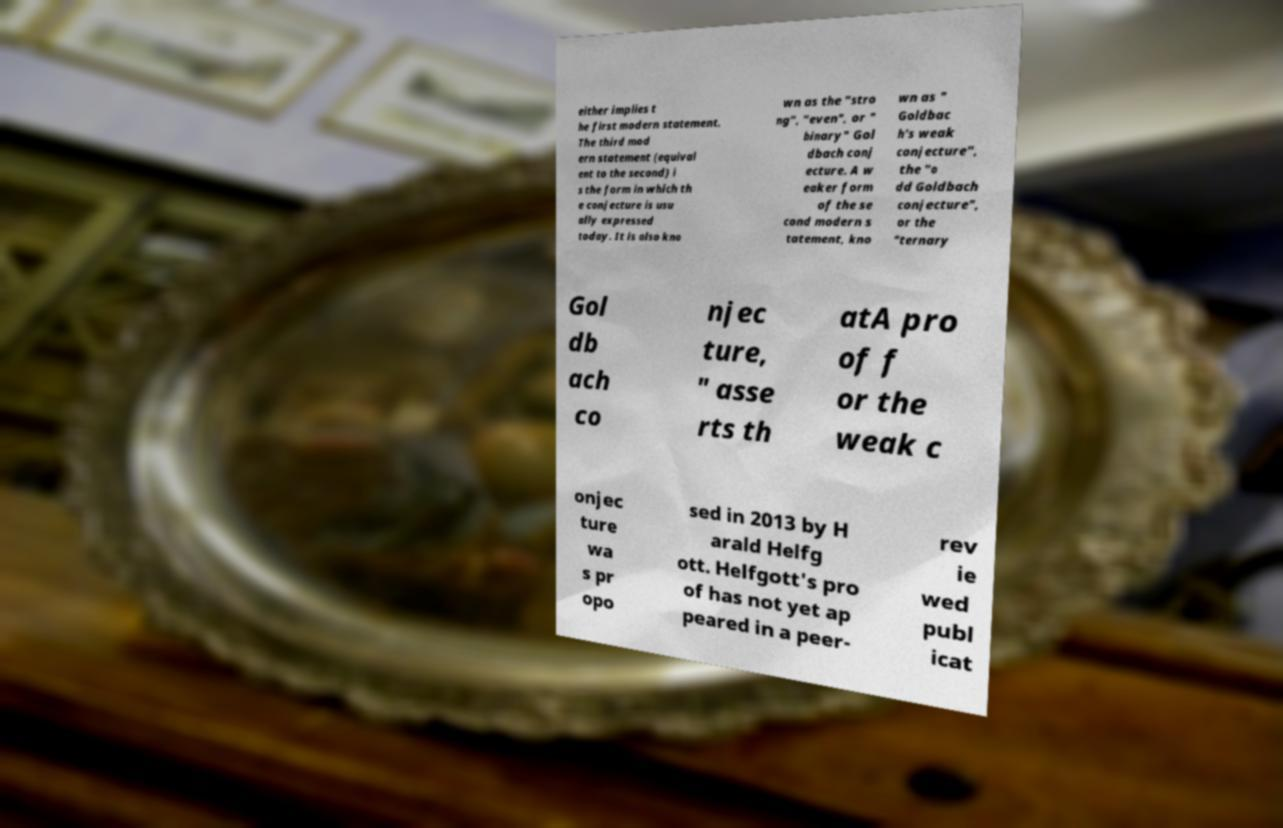For documentation purposes, I need the text within this image transcribed. Could you provide that? either implies t he first modern statement. The third mod ern statement (equival ent to the second) i s the form in which th e conjecture is usu ally expressed today. It is also kno wn as the "stro ng", "even", or " binary" Gol dbach conj ecture. A w eaker form of the se cond modern s tatement, kno wn as " Goldbac h's weak conjecture", the "o dd Goldbach conjecture", or the "ternary Gol db ach co njec ture, " asse rts th atA pro of f or the weak c onjec ture wa s pr opo sed in 2013 by H arald Helfg ott. Helfgott's pro of has not yet ap peared in a peer- rev ie wed publ icat 